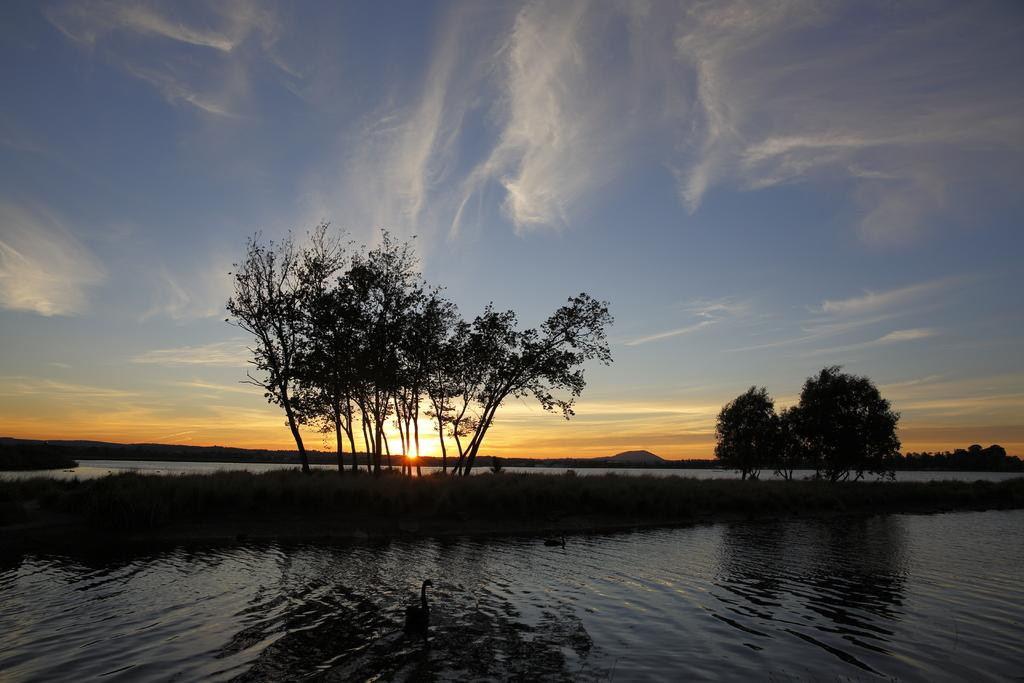What type of vegetation can be seen in the image? There are trees in the image. What natural element is visible in the image? There is water visible in the image. What can be seen in the background of the image? The sky is visible in the background of the image. What celestial body is observable in the sky? The sun is observable in the sky. Can you tell me how many farmers are participating in the battle in the image? There is no battle or farmer present in the image; it features trees, water, and the sky. What type of foot is visible in the image? There are no feet or shoes present in the image. 